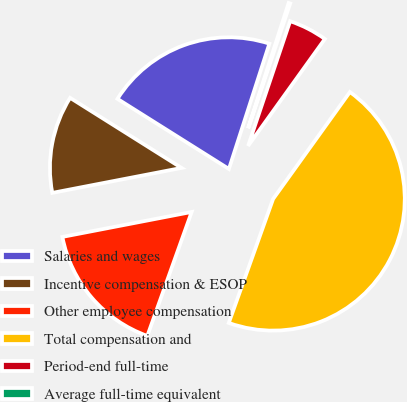Convert chart. <chart><loc_0><loc_0><loc_500><loc_500><pie_chart><fcel>Salaries and wages<fcel>Incentive compensation & ESOP<fcel>Other employee compensation<fcel>Total compensation and<fcel>Period-end full-time<fcel>Average full-time equivalent<nl><fcel>21.04%<fcel>11.97%<fcel>16.5%<fcel>45.56%<fcel>4.74%<fcel>0.2%<nl></chart> 